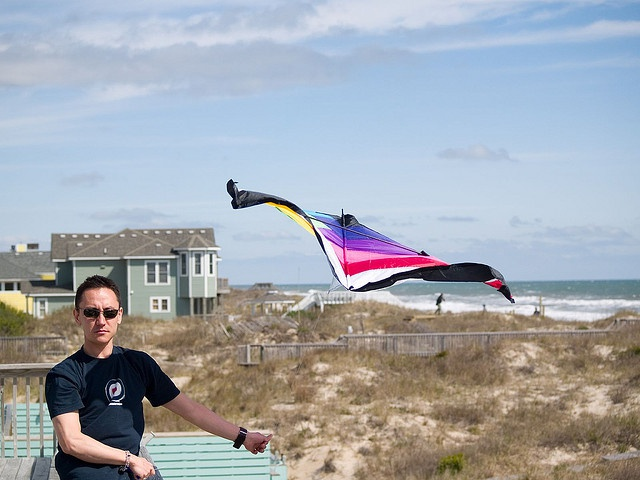Describe the objects in this image and their specific colors. I can see people in darkgray, black, gray, navy, and brown tones, kite in darkgray, black, white, brown, and violet tones, bench in darkgray, lightblue, and teal tones, people in darkgray, gray, and black tones, and people in darkgray and gray tones in this image. 